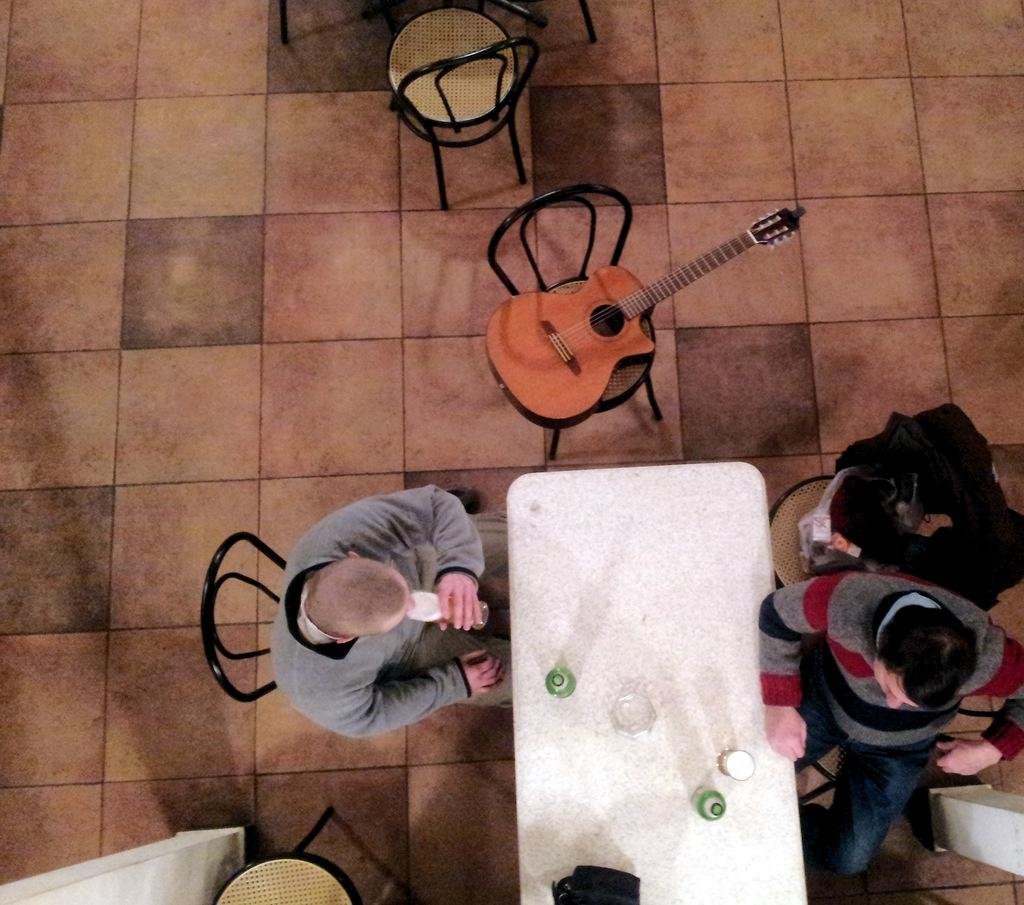How many people are in the image? There is a group of people in the image. What are the people doing in the image? The people are sitting on chairs. What is in front of the chairs? There is a table in front of the chairs. What object is placed on a chair? There is a guitar on a chair. How many toes can be seen on the guitar in the image? There are no toes visible in the image, as the guitar is an inanimate object and does not have toes. 